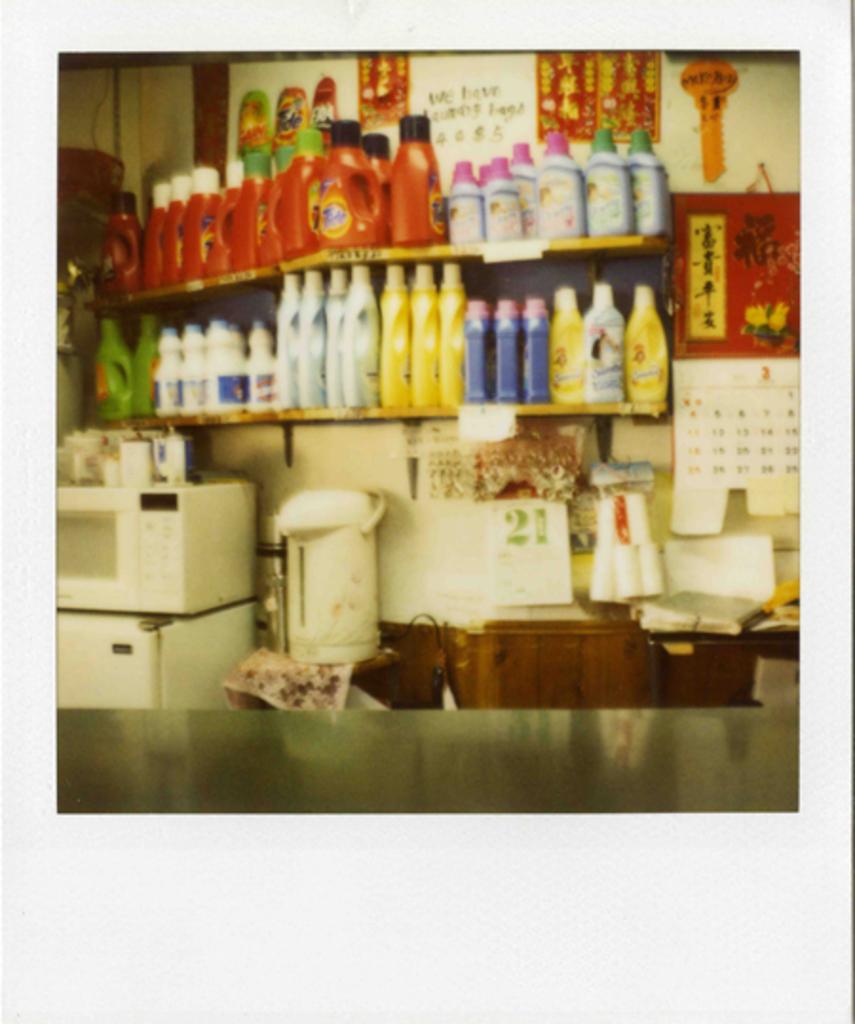What language is that in?
Provide a succinct answer. Unanswerable. 